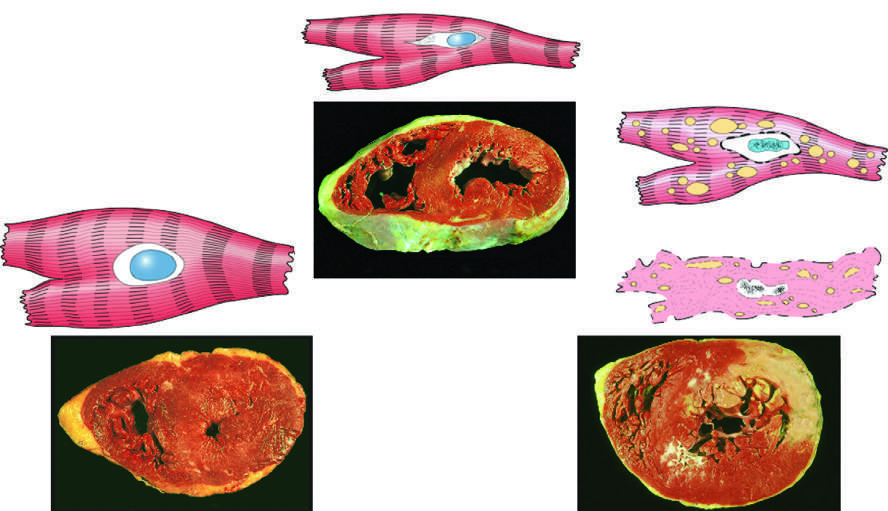s the cellular adaptation depicted here hypertrophy?
Answer the question using a single word or phrase. Yes 